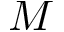Convert formula to latex. <formula><loc_0><loc_0><loc_500><loc_500>M</formula> 